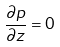<formula> <loc_0><loc_0><loc_500><loc_500>\frac { \partial p } { \partial z } = 0</formula> 